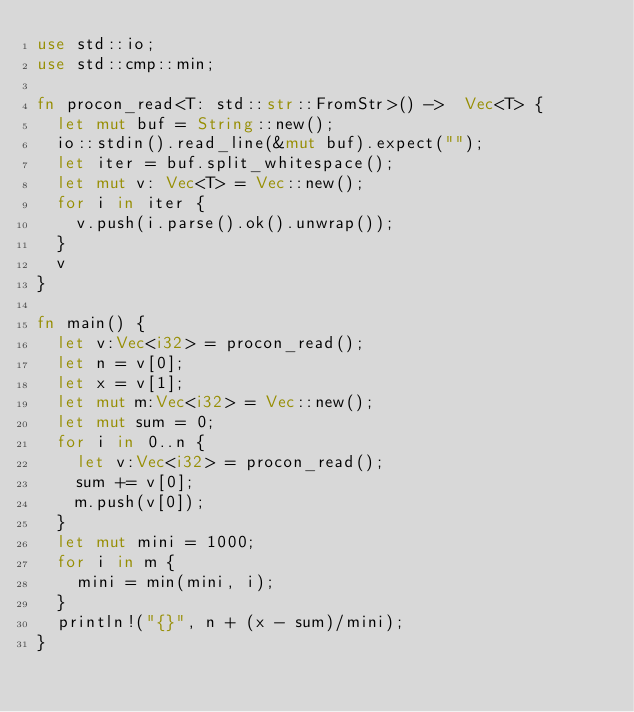Convert code to text. <code><loc_0><loc_0><loc_500><loc_500><_Rust_>use std::io;
use std::cmp::min;

fn procon_read<T: std::str::FromStr>() ->  Vec<T> {
	let mut buf = String::new();
	io::stdin().read_line(&mut buf).expect("");
	let iter = buf.split_whitespace();
	let mut v: Vec<T> = Vec::new();
	for i in iter {
		v.push(i.parse().ok().unwrap());
	}
	v
}

fn main() {
	let v:Vec<i32> = procon_read();
	let n = v[0];
	let x = v[1];
	let mut m:Vec<i32> = Vec::new();
	let mut sum = 0;
	for i in 0..n {
		let v:Vec<i32> = procon_read();
		sum += v[0];
		m.push(v[0]);
	}
	let mut mini = 1000;
	for i in m {
		mini = min(mini, i);
	}
	println!("{}", n + (x - sum)/mini);
}</code> 